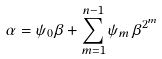<formula> <loc_0><loc_0><loc_500><loc_500>\alpha = \psi _ { 0 } \beta + \sum _ { m = 1 } ^ { n - 1 } \psi _ { m } \, \beta ^ { 2 ^ { m } }</formula> 